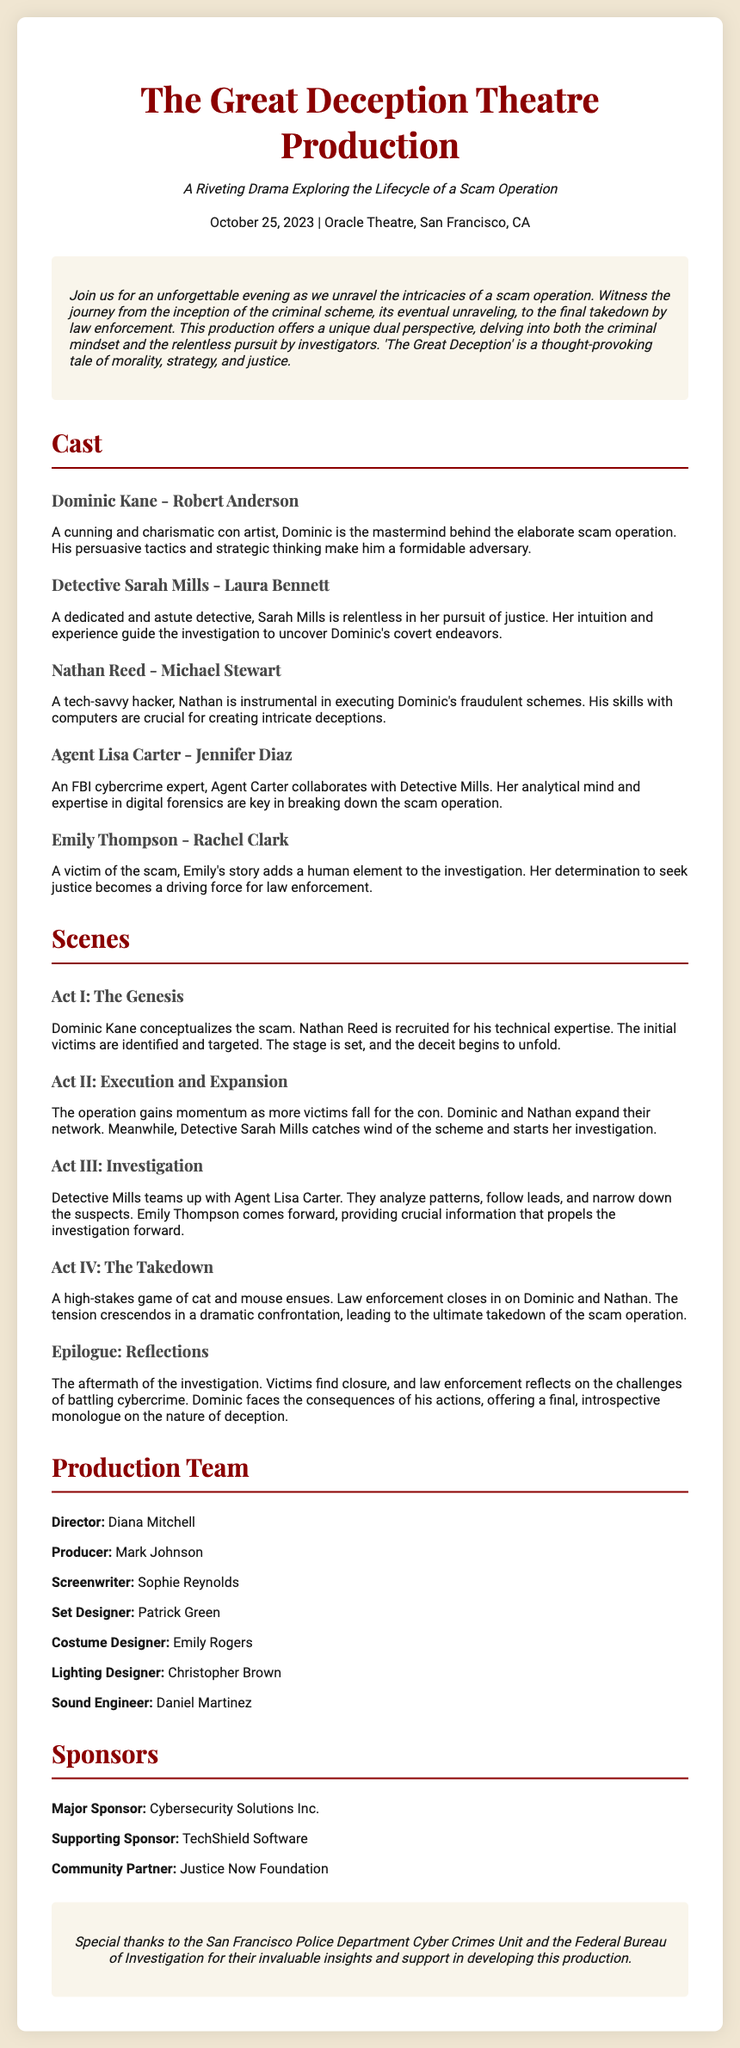What is the title of the play? The title is explicitly stated at the top of the document.
Answer: The Great Deception Theatre Production Who plays Dominic Kane? The name of the actor playing Dominic Kane is listed in the cast section.
Answer: Robert Anderson What is the date of the performance? The performance date is provided in the information section of the document.
Answer: October 25, 2023 What character is a victim of the scam? The cast section identifies the character who is a victim.
Answer: Emily Thompson How many acts are in the play? The number of acts can be counted from the list of scenes provided.
Answer: Four What role does Agent Lisa Carter play? The relationship between Agent Lisa Carter and her occupation is mentioned in the cast section.
Answer: FBI cybercrime expert Who is the director of the production? The document lists names and roles in the production team section, including the director.
Answer: Diana Mitchell Which organization is the major sponsor? The sponsors section lists the names of the sponsors, including the major one.
Answer: Cybersecurity Solutions Inc What is the central theme of the play? The summary describes the central theme as exploring the lifecycle of a scam operation and law enforcement.
Answer: The lifecycle of a scam operation 